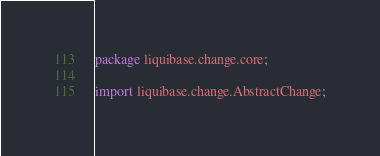<code> <loc_0><loc_0><loc_500><loc_500><_Java_>package liquibase.change.core;

import liquibase.change.AbstractChange;</code> 